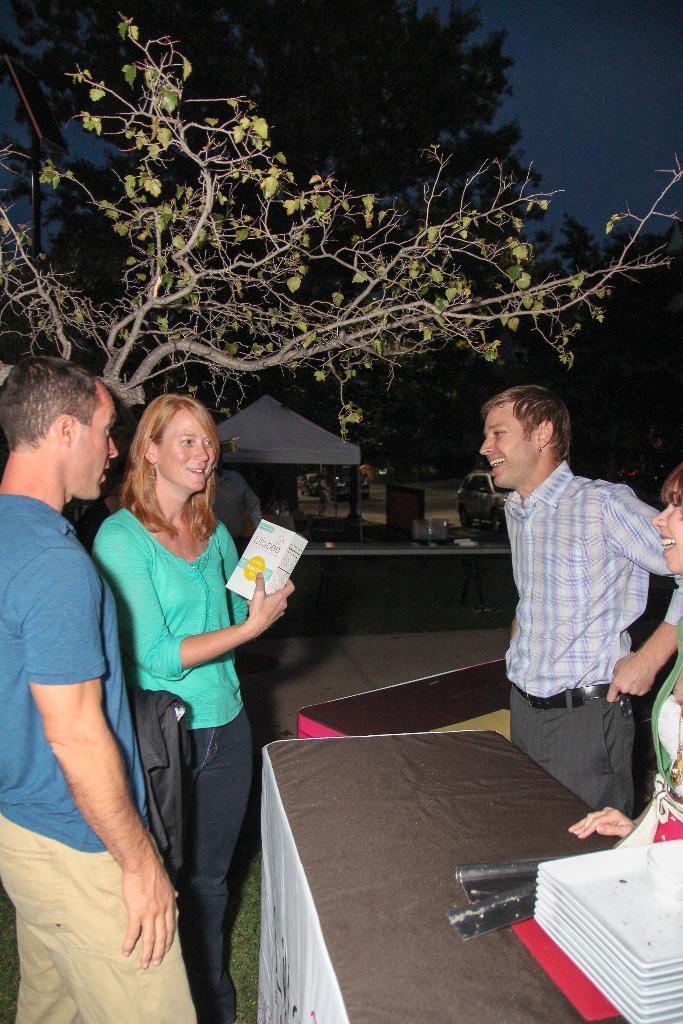Describe this image in one or two sentences. Here we can see a group of people are standing and smiling, and in front there is the table and some objects on it, and here is the tree, and at above here is the sky. 